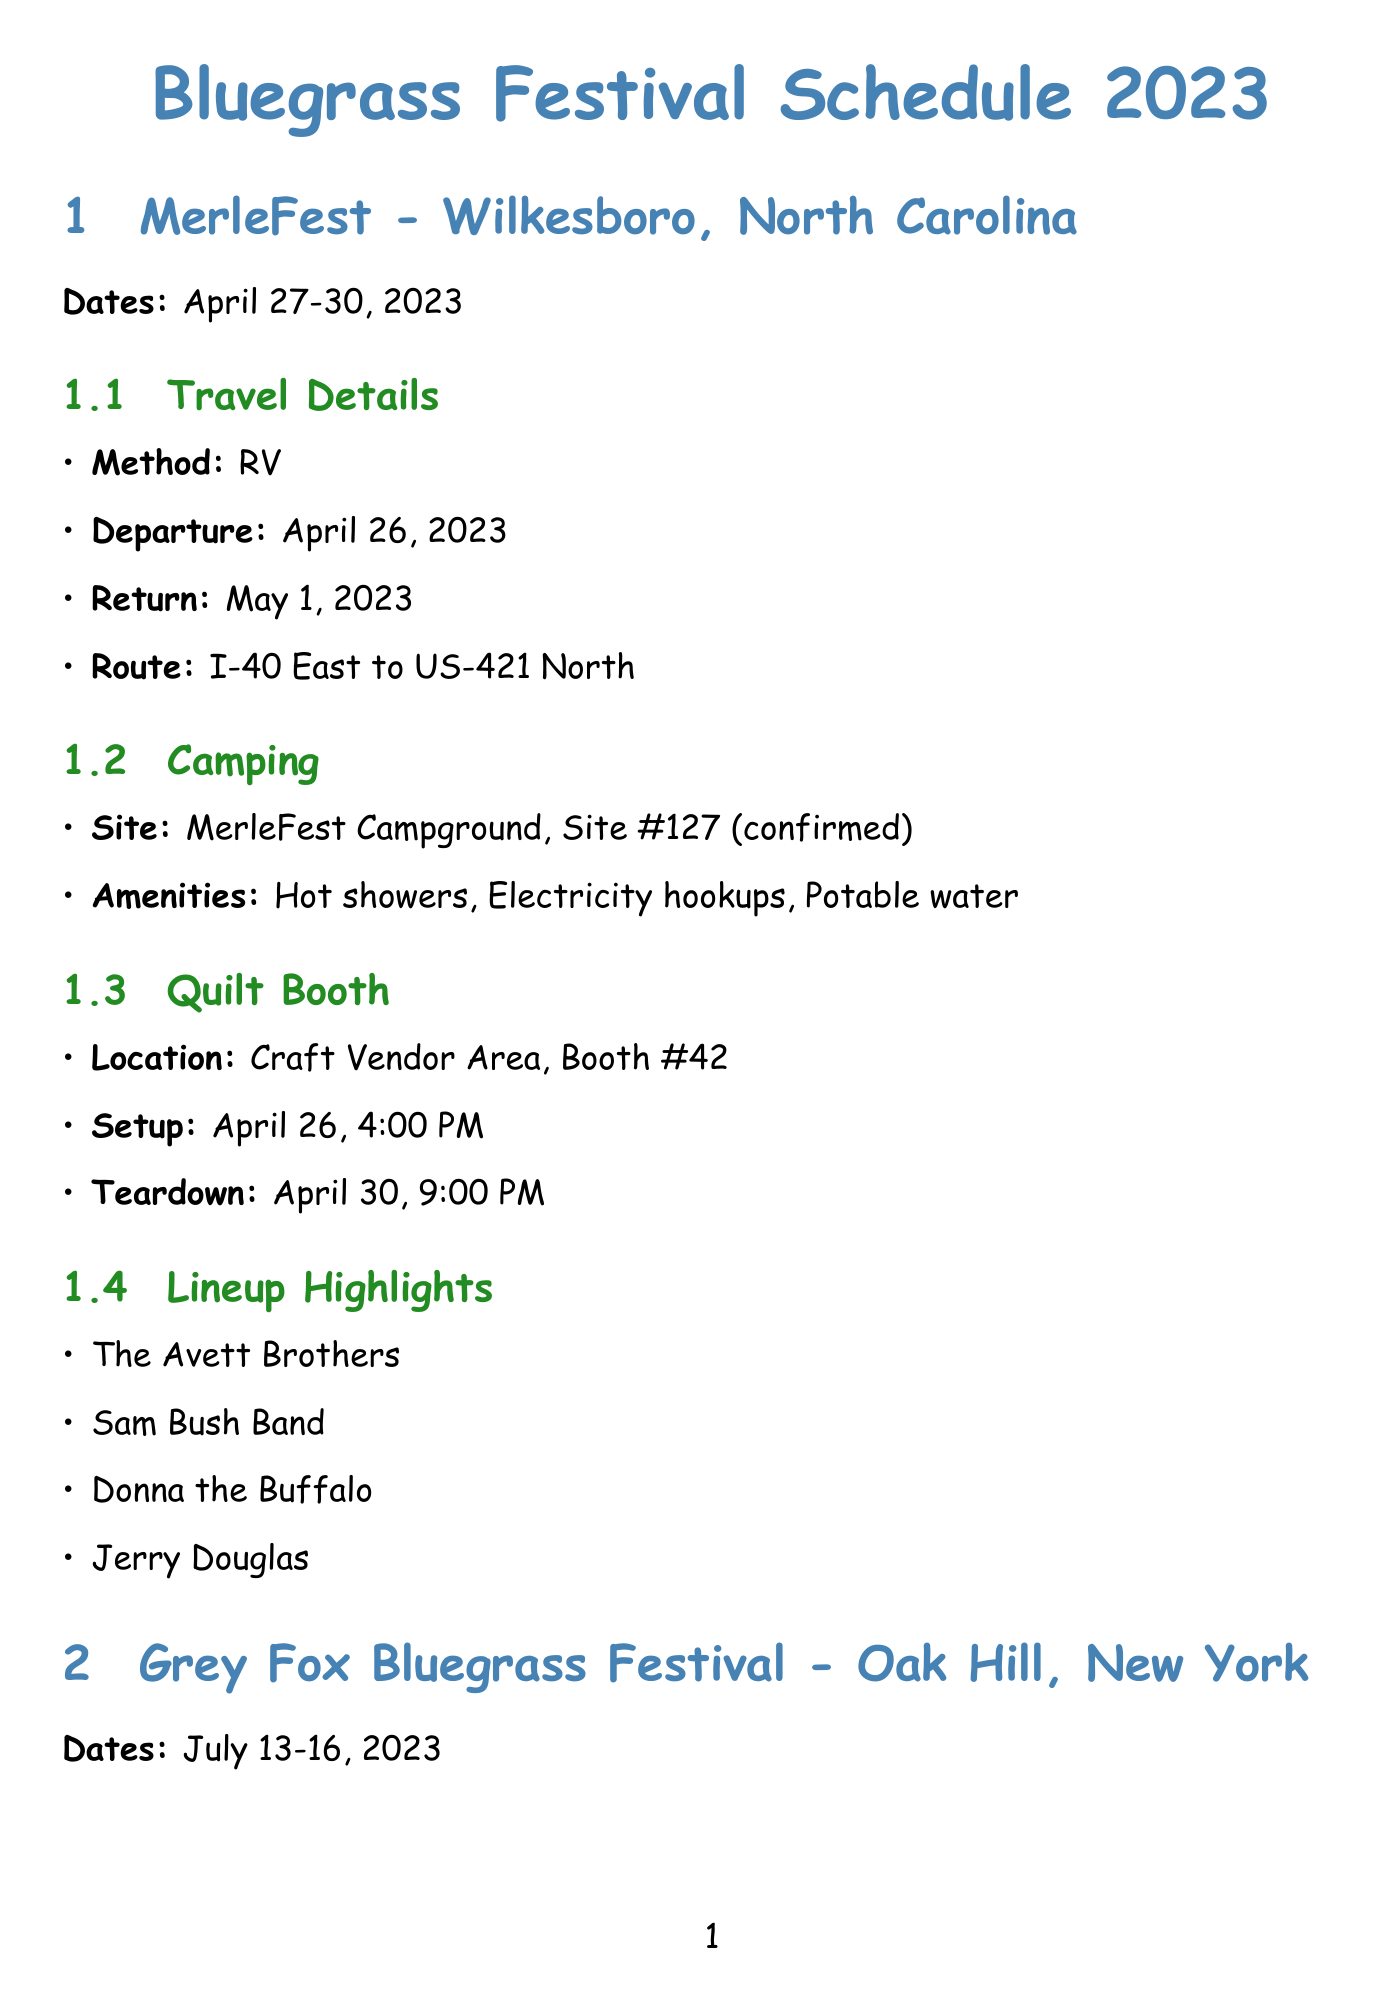What are the dates for the MerleFest? The dates provided in the document specifically for MerleFest are listed as April 27-30, 2023.
Answer: April 27-30, 2023 Which travel method is used for the Grey Fox Bluegrass Festival? The document indicates that the travel method for the Grey Fox Bluegrass Festival is by car with a camping trailer.
Answer: Car with camping trailer What is the lineup highlight at ROMP Fest? The lineup for ROMP Fest includes multiple bands, one of which is the Punch Brothers, listed in the document.
Answer: Punch Brothers What is the camping site for MerleFest? The document specifies MerleFest Campground as the camping site for attending this festival.
Answer: MerleFest Campground What time is the quilt booth setup for ROMP Fest? The creation document states that the setup for the quilt booth at ROMP Fest is at 9:00 AM on June 21.
Answer: 9:00 AM How many quilts for sale are listed in the packing list? The packing list mentions that there are 20 assorted sizes of quilts for sale, as detailed in the document.
Answer: 20 What is the route for traveling to Grey Fox Bluegrass Festival? The document includes the travel route for this festival, noted as I-81 North to I-88 East, then NY-32 North.
Answer: I-81 North to I-88 East, then NY-32 North What is included in the camping amenities for ROMP Fest? The document highlights camping amenities including showers, picnic tables, and fire pits as part of the offerings for ROMP Fest.
Answer: Showers, picnic tables, fire pits What booth number is the quilt booth located in at Grey Fox Festival? According to the document, the quilt booth is set up in Space #23 at the Handmade Village for Grey Fox Festival.
Answer: Space #23 